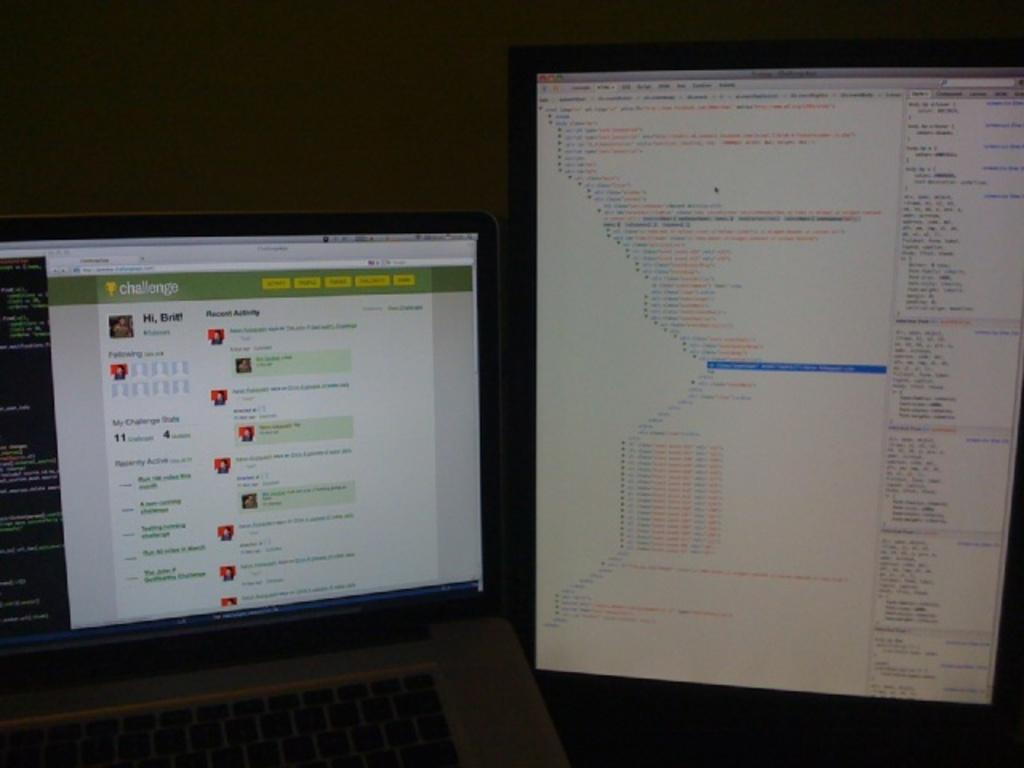<image>
Share a concise interpretation of the image provided. A Challenge page has comments on it like a social network. 